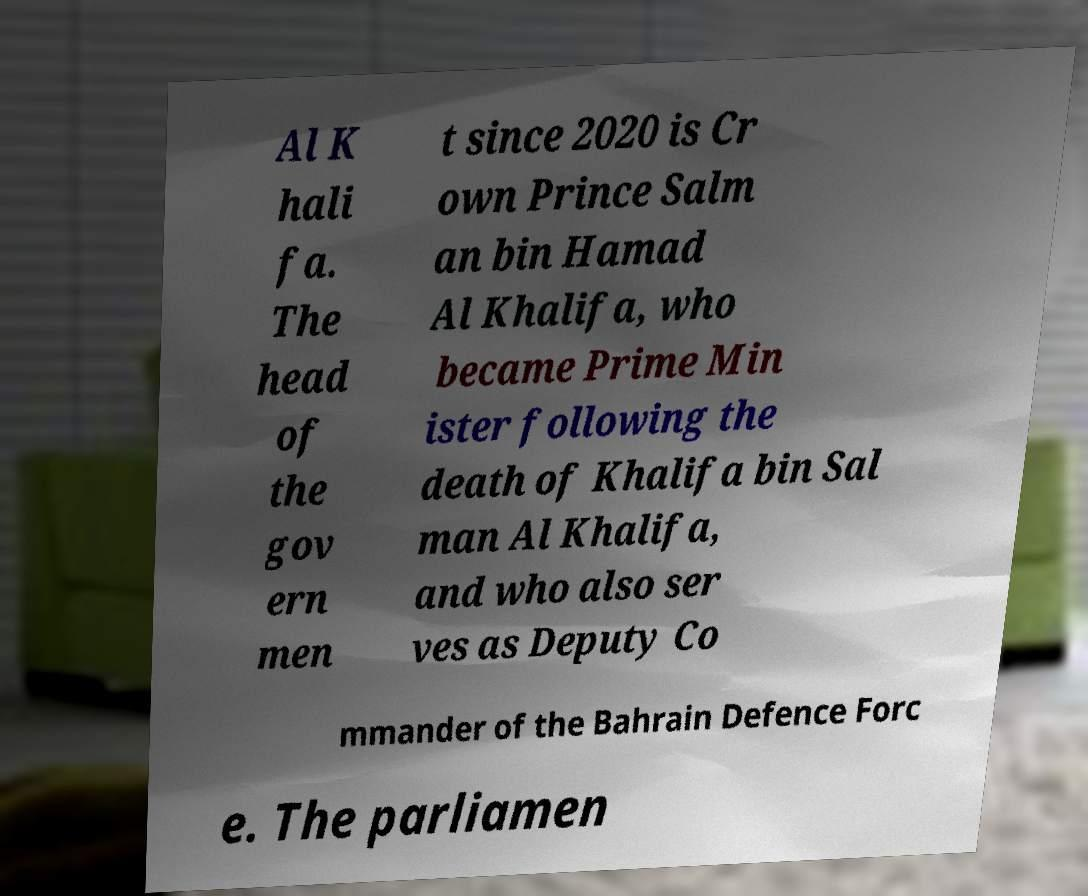Can you accurately transcribe the text from the provided image for me? Al K hali fa. The head of the gov ern men t since 2020 is Cr own Prince Salm an bin Hamad Al Khalifa, who became Prime Min ister following the death of Khalifa bin Sal man Al Khalifa, and who also ser ves as Deputy Co mmander of the Bahrain Defence Forc e. The parliamen 